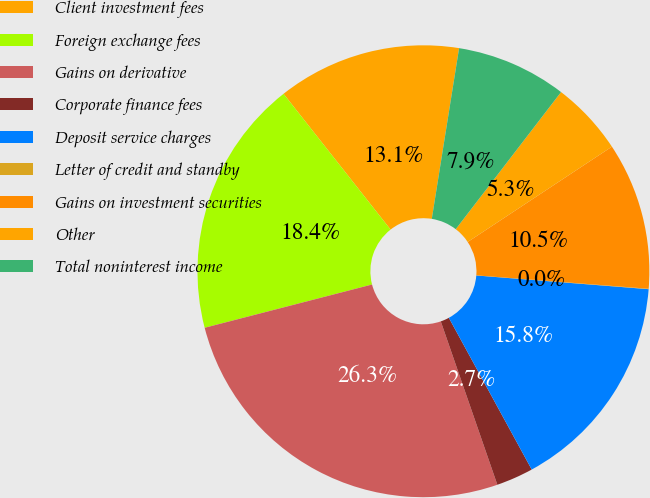<chart> <loc_0><loc_0><loc_500><loc_500><pie_chart><fcel>Client investment fees<fcel>Foreign exchange fees<fcel>Gains on derivative<fcel>Corporate finance fees<fcel>Deposit service charges<fcel>Letter of credit and standby<fcel>Gains on investment securities<fcel>Other<fcel>Total noninterest income<nl><fcel>13.15%<fcel>18.4%<fcel>26.28%<fcel>2.65%<fcel>15.78%<fcel>0.03%<fcel>10.53%<fcel>5.28%<fcel>7.9%<nl></chart> 